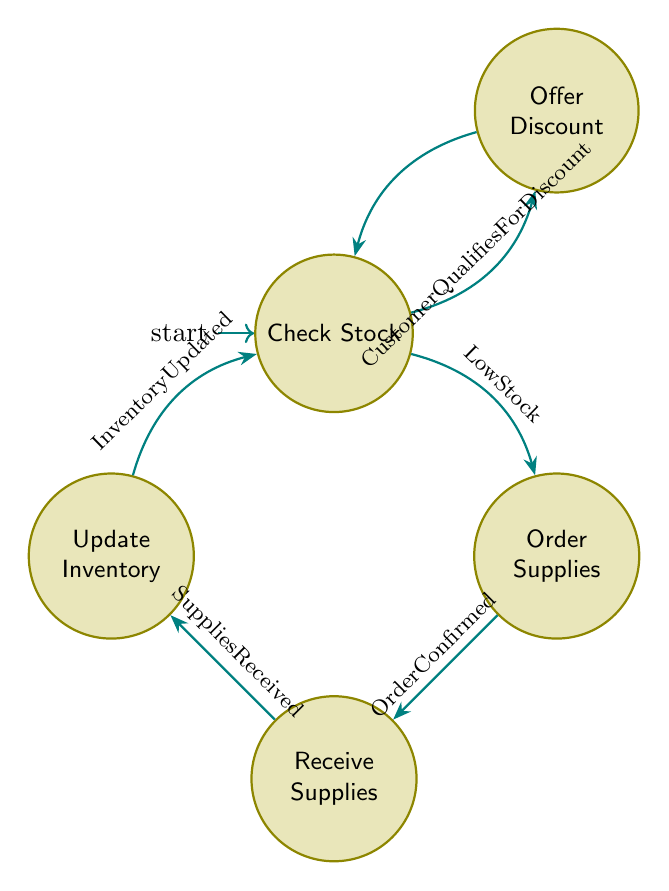What is the initial state in the diagram? The initial state is typically indicated as the first node in the flow, which in this diagram is labeled "Check Stock".
Answer: Check Stock How many states are present in the diagram? By counting the distinct circles representing states in the diagram, it is determined that there are five states: Check Stock, Order Supplies, Receive Supplies, Update Inventory, and Offer Discount.
Answer: Five What is the transition condition from "Receive Supplies" to "Update Inventory"? The transition from "Receive Supplies" to "Update Inventory" is conditioned upon the status “Supplies Received”, as indicated by the label on the edge between these two states.
Answer: Supplies Received If the inventory is updated, which state do we return to next? Following the update of inventory, the flow of the diagram indicates that we transition back to the "Check Stock" state for further actions or checks.
Answer: Check Stock What state is offered discounts to customers? The state associated with offering discounts is explicitly shown as "Offer Discount" in the diagram, connected to the Check Stock state.
Answer: Offer Discount What transition occurs if the stock is low? In the event of low stock, the transition specified would lead from "Check Stock" to "Order Supplies" for restocking purposes.
Answer: Order Supplies If the customer qualifies for a discount, which state do we move to? Upon verifying that a customer qualifies for a discount, the diagram indicates a transition from "Check Stock" to "Offer Discount".
Answer: Offer Discount What follows the "Order Supplies" state? After the "Order Supplies" state is an action that leads to the "Receive Supplies" state, contingent on an "Order Confirmed" condition.
Answer: Receive Supplies What do we do after updating the inventory? After updating the inventory, the next action is to return to the "Check Stock" state, allowing for a reassessment of stock levels.
Answer: Check Stock 